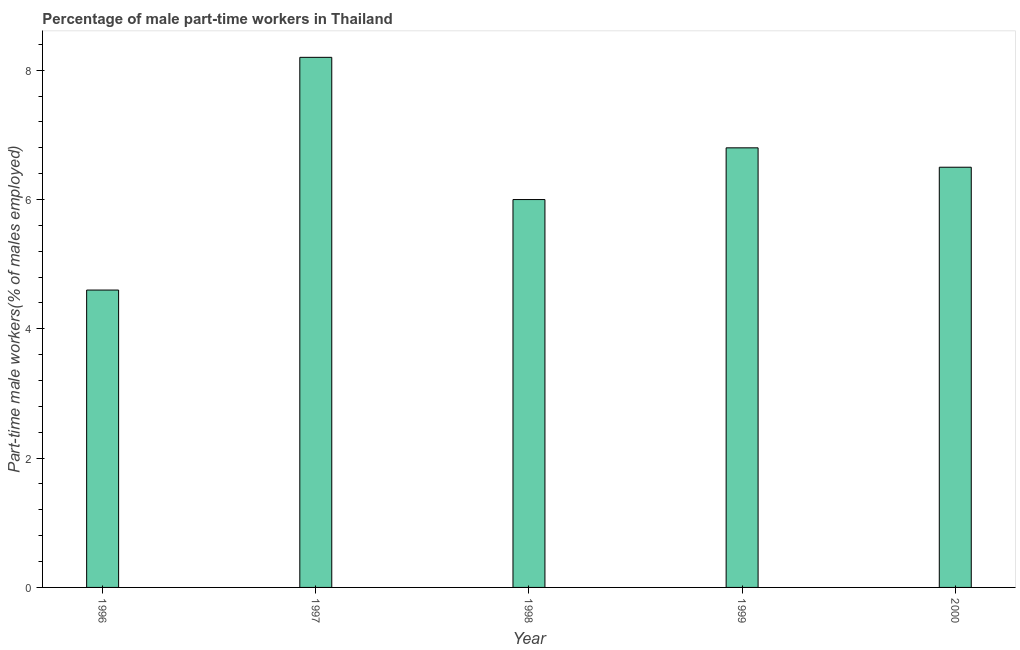What is the title of the graph?
Provide a short and direct response. Percentage of male part-time workers in Thailand. What is the label or title of the X-axis?
Give a very brief answer. Year. What is the label or title of the Y-axis?
Your answer should be compact. Part-time male workers(% of males employed). What is the percentage of part-time male workers in 2000?
Your response must be concise. 6.5. Across all years, what is the maximum percentage of part-time male workers?
Make the answer very short. 8.2. Across all years, what is the minimum percentage of part-time male workers?
Keep it short and to the point. 4.6. In which year was the percentage of part-time male workers minimum?
Your answer should be very brief. 1996. What is the sum of the percentage of part-time male workers?
Offer a very short reply. 32.1. What is the difference between the percentage of part-time male workers in 1999 and 2000?
Keep it short and to the point. 0.3. What is the average percentage of part-time male workers per year?
Ensure brevity in your answer.  6.42. What is the ratio of the percentage of part-time male workers in 1998 to that in 2000?
Your answer should be compact. 0.92. What is the difference between the highest and the second highest percentage of part-time male workers?
Offer a terse response. 1.4. What is the difference between the highest and the lowest percentage of part-time male workers?
Keep it short and to the point. 3.6. What is the difference between two consecutive major ticks on the Y-axis?
Offer a terse response. 2. What is the Part-time male workers(% of males employed) in 1996?
Offer a very short reply. 4.6. What is the Part-time male workers(% of males employed) of 1997?
Offer a very short reply. 8.2. What is the Part-time male workers(% of males employed) of 1999?
Offer a very short reply. 6.8. What is the difference between the Part-time male workers(% of males employed) in 1996 and 1998?
Offer a very short reply. -1.4. What is the difference between the Part-time male workers(% of males employed) in 1997 and 1999?
Offer a terse response. 1.4. What is the difference between the Part-time male workers(% of males employed) in 1997 and 2000?
Ensure brevity in your answer.  1.7. What is the difference between the Part-time male workers(% of males employed) in 1998 and 2000?
Provide a short and direct response. -0.5. What is the ratio of the Part-time male workers(% of males employed) in 1996 to that in 1997?
Offer a very short reply. 0.56. What is the ratio of the Part-time male workers(% of males employed) in 1996 to that in 1998?
Provide a succinct answer. 0.77. What is the ratio of the Part-time male workers(% of males employed) in 1996 to that in 1999?
Offer a terse response. 0.68. What is the ratio of the Part-time male workers(% of males employed) in 1996 to that in 2000?
Provide a short and direct response. 0.71. What is the ratio of the Part-time male workers(% of males employed) in 1997 to that in 1998?
Ensure brevity in your answer.  1.37. What is the ratio of the Part-time male workers(% of males employed) in 1997 to that in 1999?
Offer a terse response. 1.21. What is the ratio of the Part-time male workers(% of males employed) in 1997 to that in 2000?
Provide a short and direct response. 1.26. What is the ratio of the Part-time male workers(% of males employed) in 1998 to that in 1999?
Make the answer very short. 0.88. What is the ratio of the Part-time male workers(% of males employed) in 1998 to that in 2000?
Offer a very short reply. 0.92. What is the ratio of the Part-time male workers(% of males employed) in 1999 to that in 2000?
Provide a short and direct response. 1.05. 